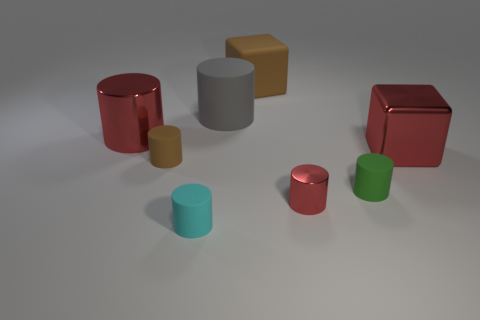The large thing that is the same color as the metallic cube is what shape?
Your response must be concise. Cylinder. Is the material of the red cube the same as the large gray thing?
Your response must be concise. No. How many green cylinders are in front of the big block that is in front of the large red object on the left side of the metallic cube?
Provide a succinct answer. 1. There is a metal cylinder that is left of the cyan cylinder; what is its color?
Offer a very short reply. Red. There is a brown rubber thing in front of the red cylinder that is behind the green object; what is its shape?
Provide a succinct answer. Cylinder. Is the color of the big matte cylinder the same as the shiny cube?
Keep it short and to the point. No. What number of spheres are either tiny brown things or gray rubber objects?
Your response must be concise. 0. There is a small object that is in front of the green thing and on the left side of the large gray rubber object; what is it made of?
Make the answer very short. Rubber. What number of blocks are behind the shiny cube?
Provide a short and direct response. 1. Do the large thing that is to the right of the small shiny cylinder and the green cylinder behind the tiny cyan object have the same material?
Offer a very short reply. No. 